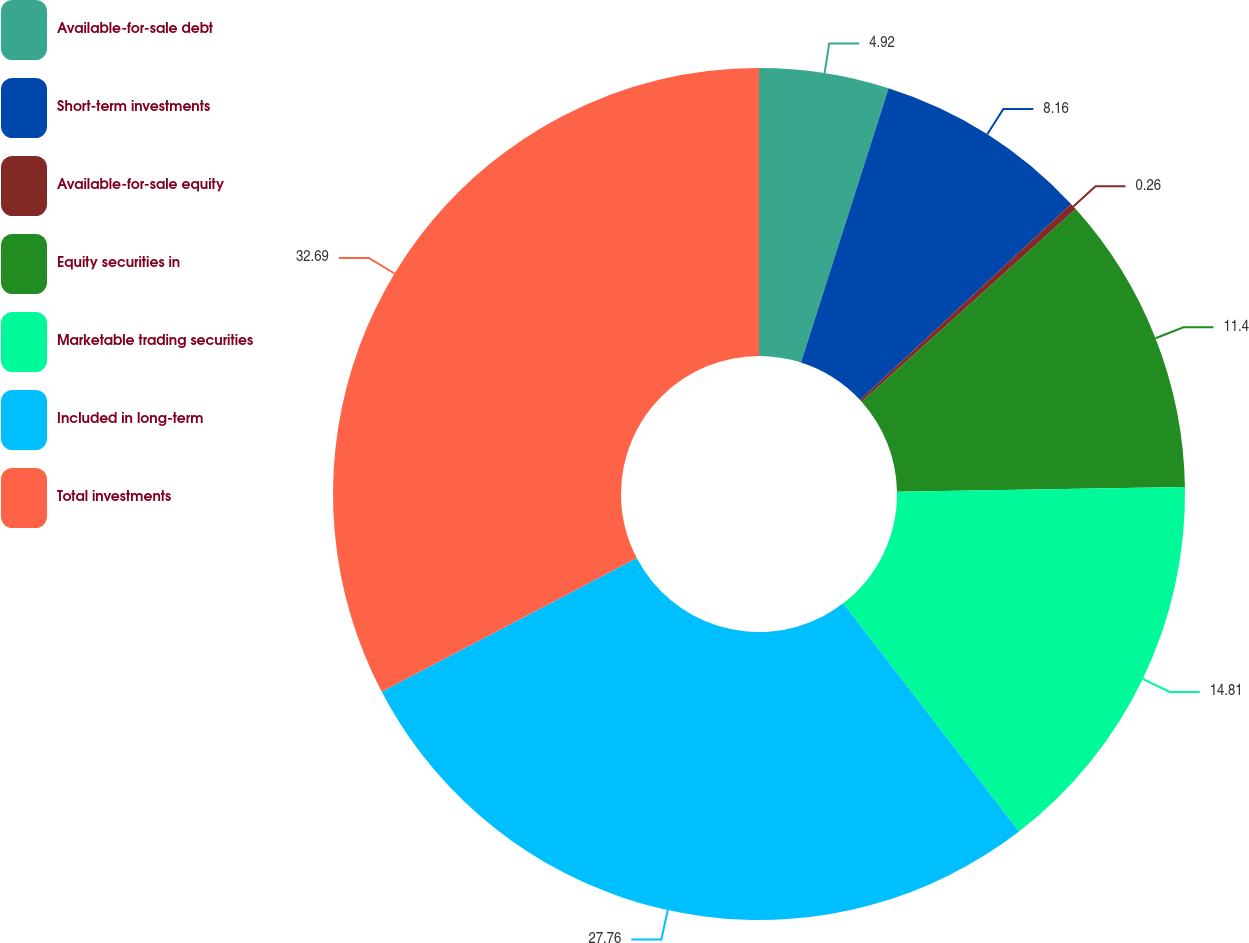Convert chart. <chart><loc_0><loc_0><loc_500><loc_500><pie_chart><fcel>Available-for-sale debt<fcel>Short-term investments<fcel>Available-for-sale equity<fcel>Equity securities in<fcel>Marketable trading securities<fcel>Included in long-term<fcel>Total investments<nl><fcel>4.92%<fcel>8.16%<fcel>0.26%<fcel>11.4%<fcel>14.81%<fcel>27.76%<fcel>32.68%<nl></chart> 